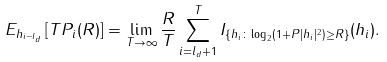<formula> <loc_0><loc_0><loc_500><loc_500>E _ { h _ { i - l _ { d } } } \left [ T P _ { i } ( R ) \right ] = \lim _ { T \rightarrow \infty } \frac { R } { T } \sum _ { i = l _ { d } + 1 } ^ { T } I _ { \{ h _ { i } \colon \log _ { 2 } ( 1 + P | h _ { i } | ^ { 2 } ) \geq R \} } ( h _ { i } ) .</formula> 